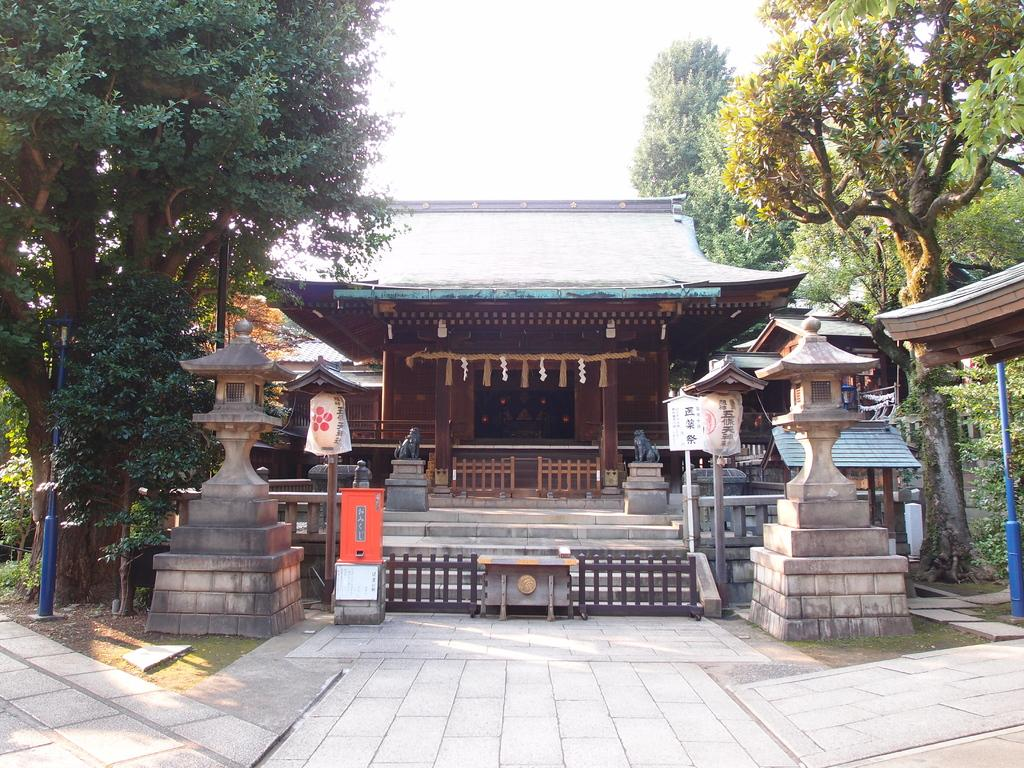What type of structure is visible in the image? There is a building in the image. What other objects can be seen in the image? There are trees, poles, railing, boards, and a road visible in the image. What is visible in the background of the image? Trees and the sky are visible in the background of the image. What type of camera is the father using to take a picture of the tramp in the image? There is no camera, father, or tramp present in the image. 